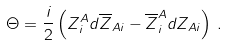Convert formula to latex. <formula><loc_0><loc_0><loc_500><loc_500>\Theta = \frac { i } { 2 } \left ( Z ^ { A } _ { i } d \overline { Z } _ { A i } - \overline { Z } ^ { A } _ { i } d Z _ { A i } \right ) \, .</formula> 